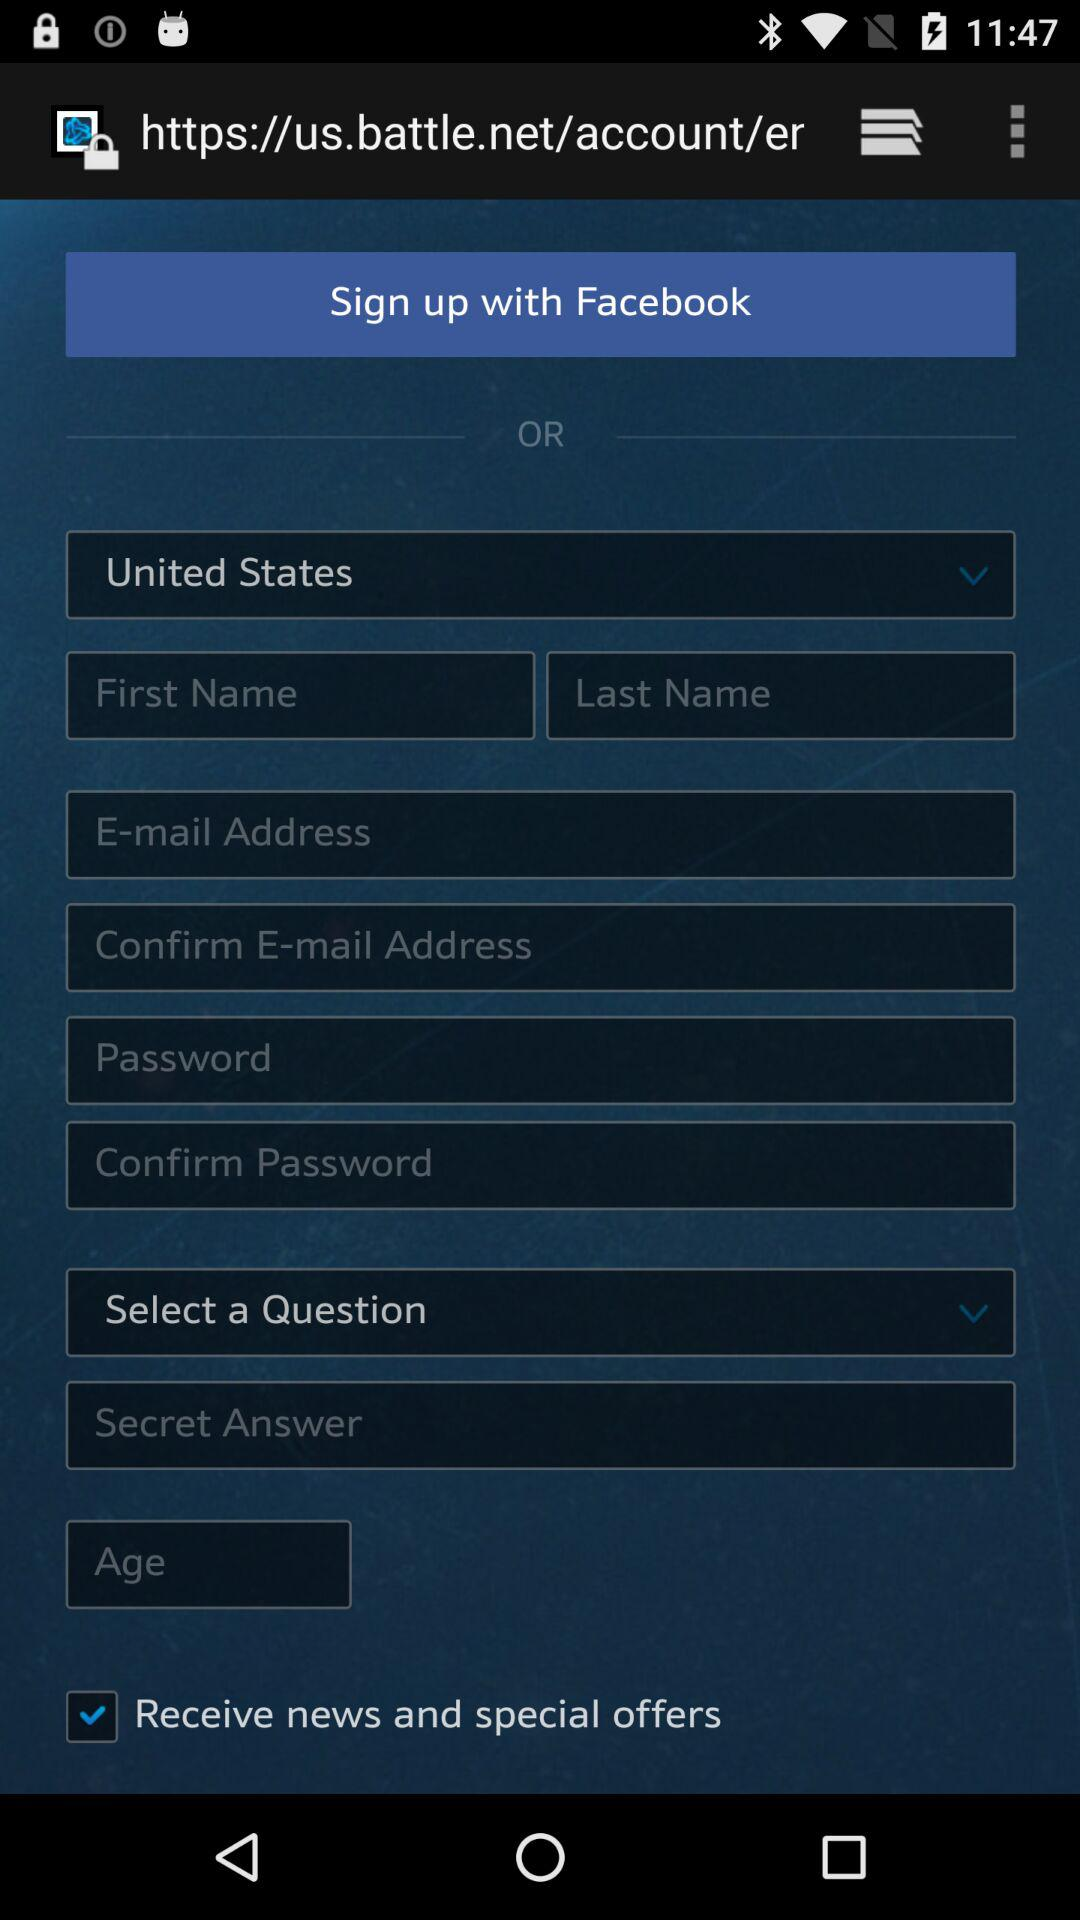What is the status of "Receive news and special offers"? The status is "on". 